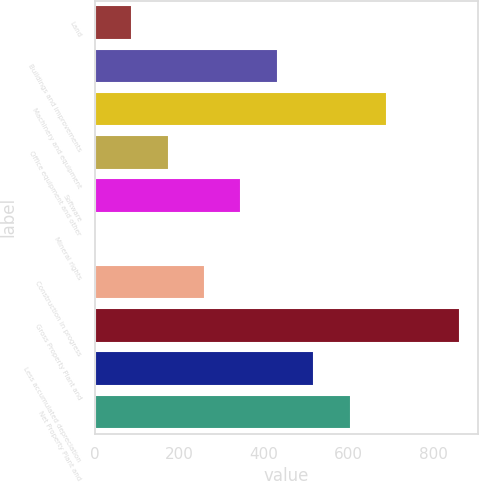Convert chart. <chart><loc_0><loc_0><loc_500><loc_500><bar_chart><fcel>Land<fcel>Buildings and improvements<fcel>Machinery and equipment<fcel>Office equipment and other<fcel>Software<fcel>Mineral rights<fcel>Construction in progress<fcel>Gross Property Plant and<fcel>Less accumulated depreciation<fcel>Net Property Plant and<nl><fcel>87.76<fcel>432.4<fcel>690.88<fcel>173.92<fcel>346.24<fcel>1.6<fcel>260.08<fcel>863.2<fcel>518.56<fcel>604.72<nl></chart> 